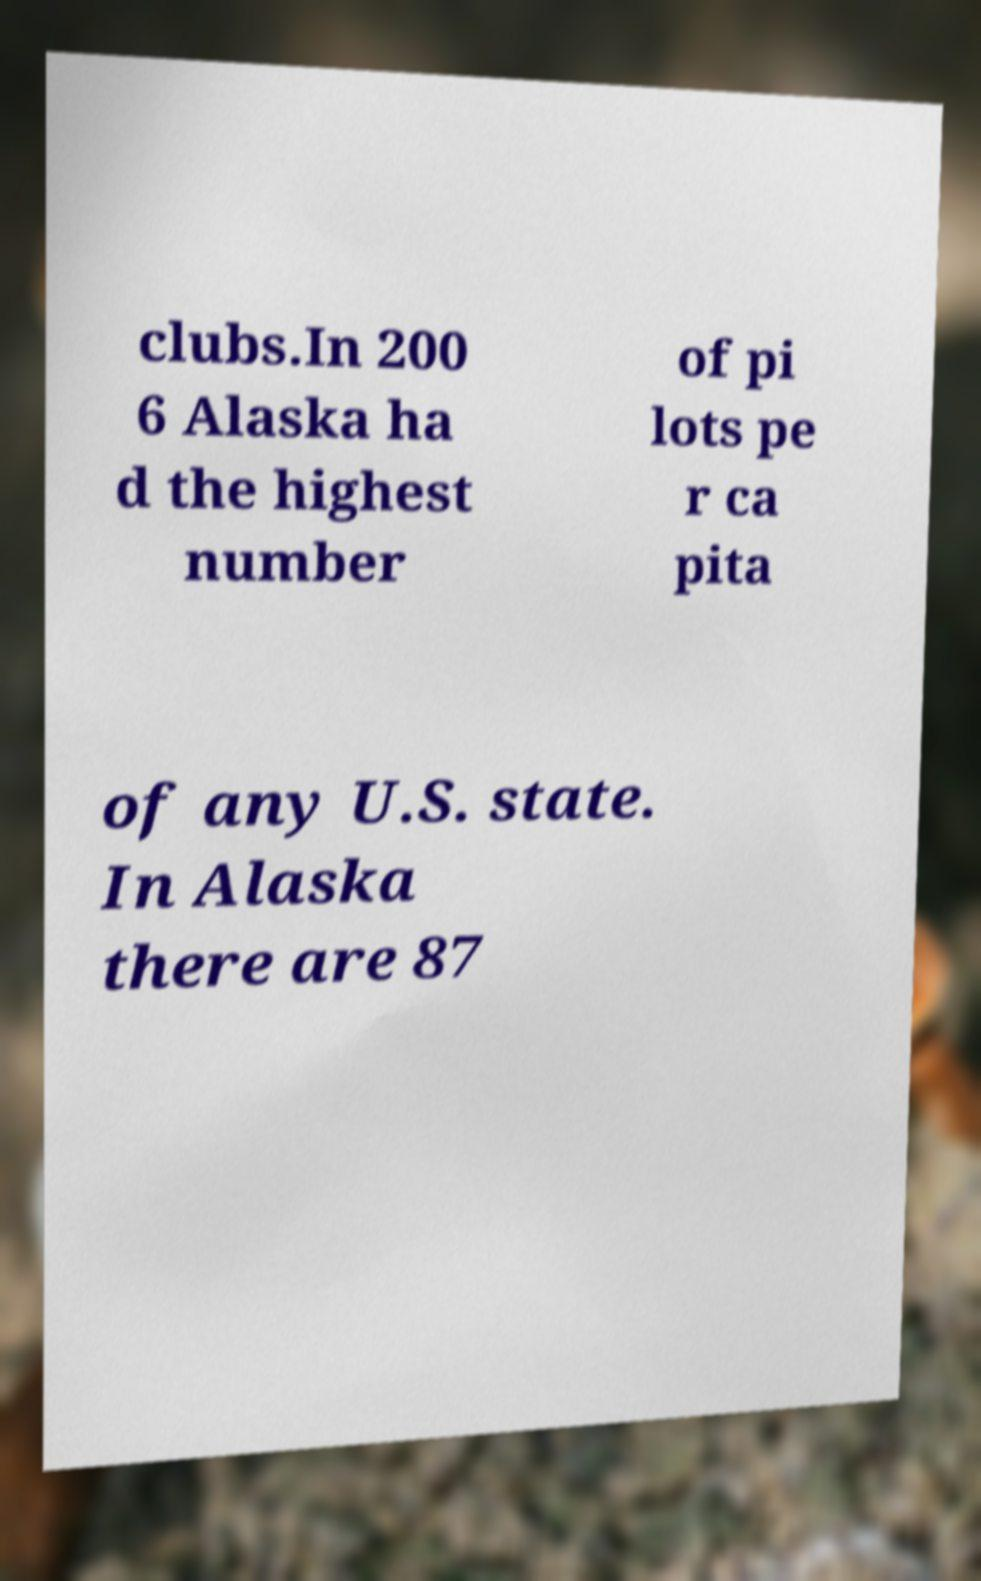What messages or text are displayed in this image? I need them in a readable, typed format. clubs.In 200 6 Alaska ha d the highest number of pi lots pe r ca pita of any U.S. state. In Alaska there are 87 